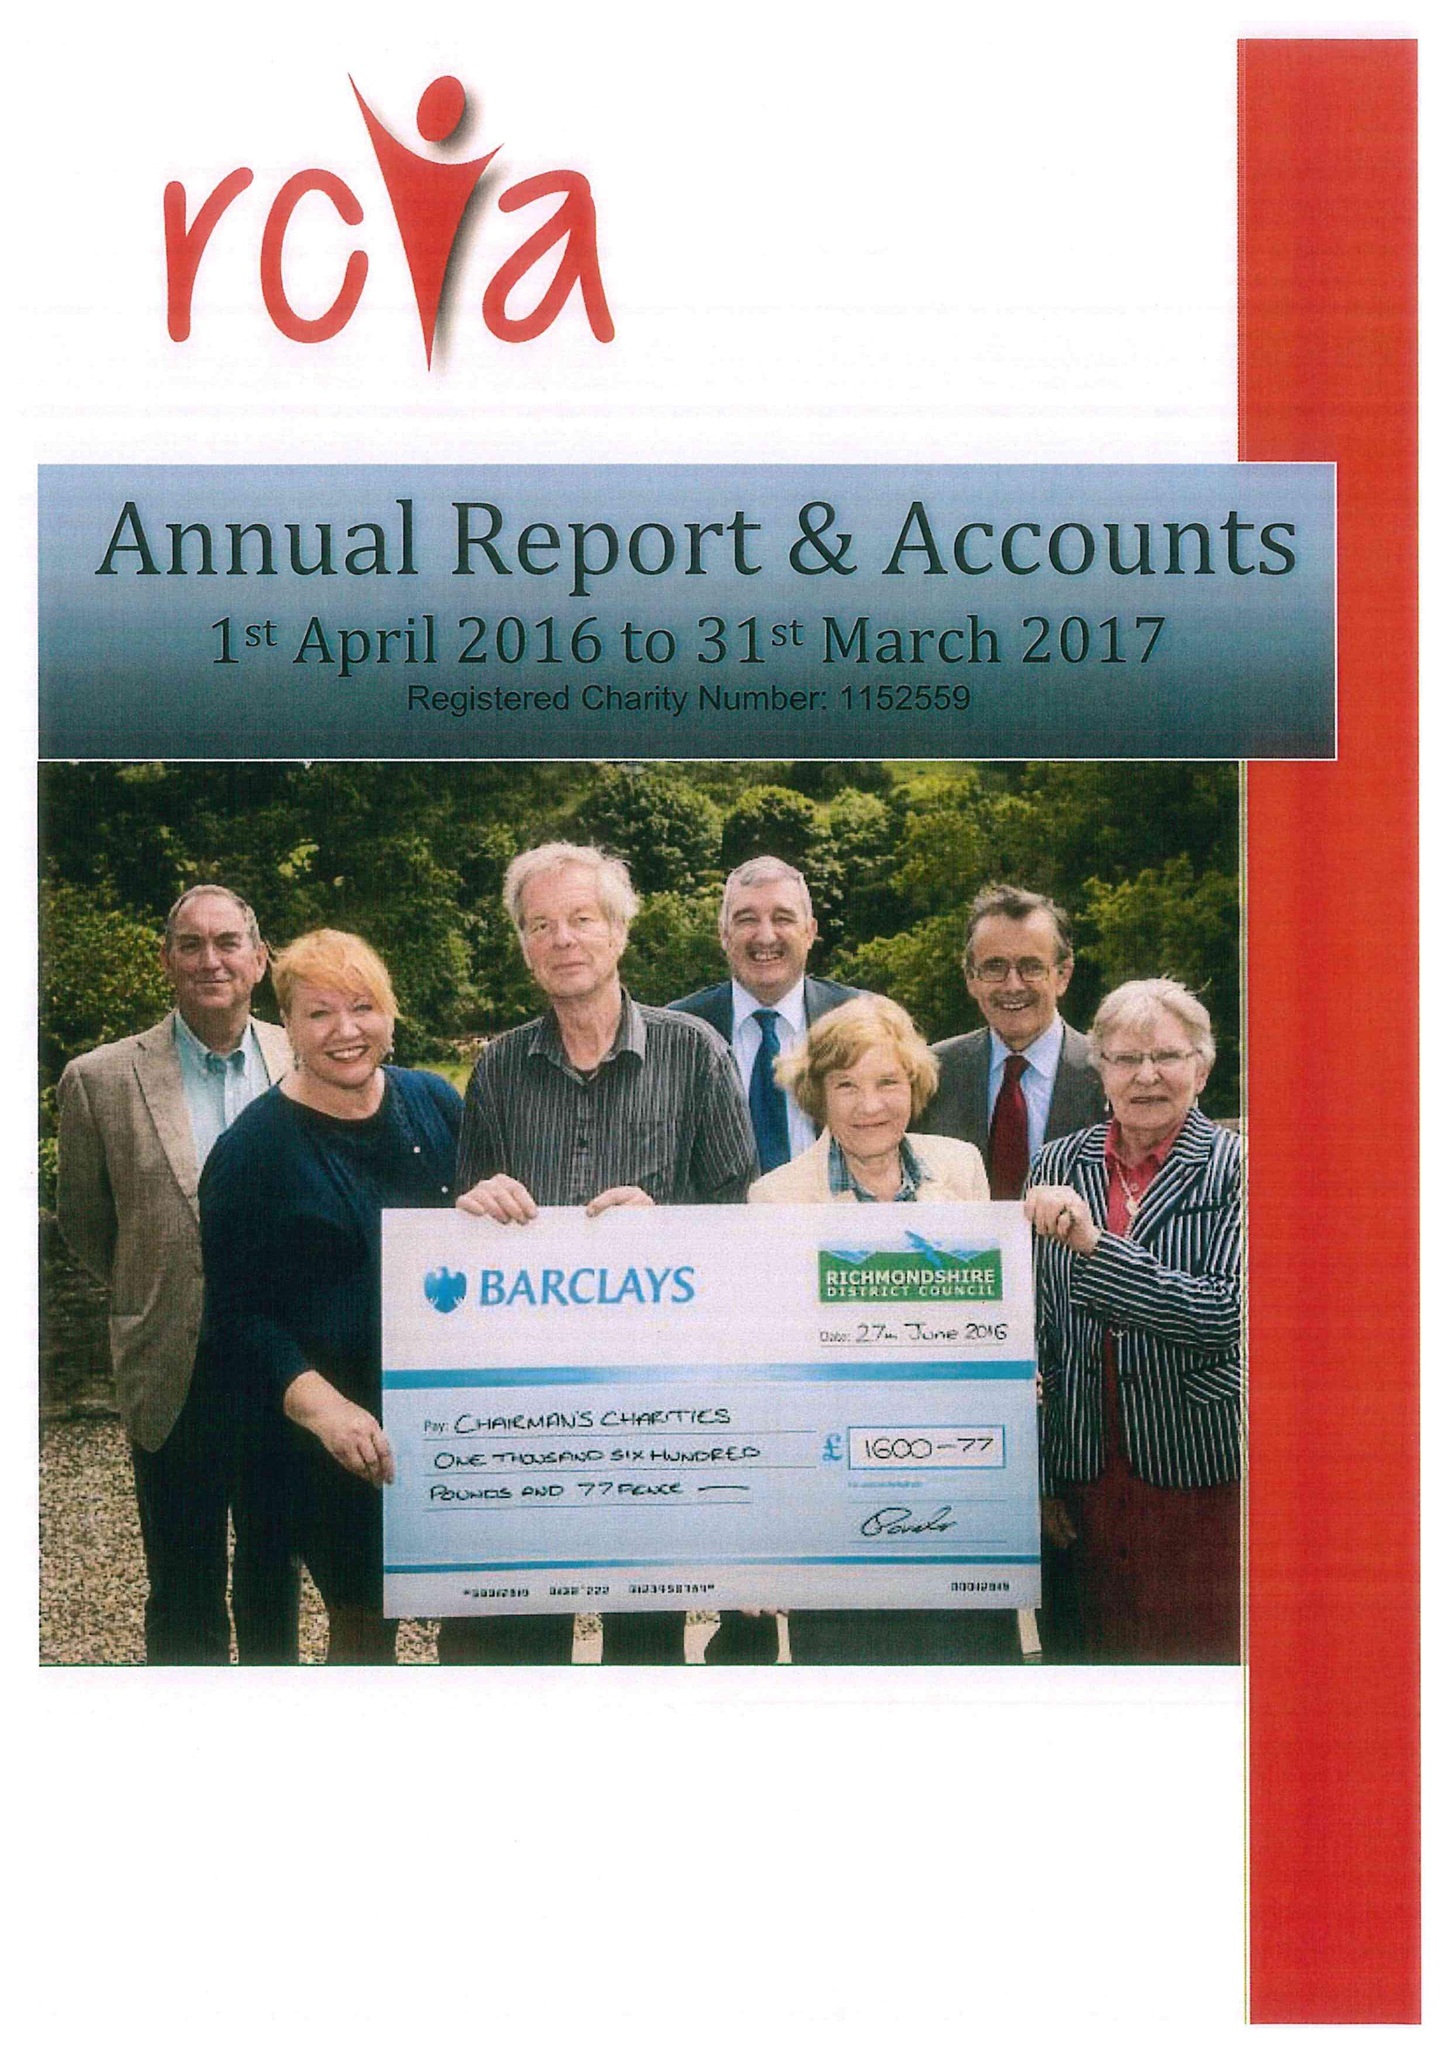What is the value for the address__street_line?
Answer the question using a single word or phrase. SHUTE ROAD 